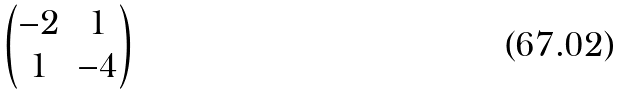Convert formula to latex. <formula><loc_0><loc_0><loc_500><loc_500>\begin{pmatrix} - 2 & 1 \\ 1 & - 4 \end{pmatrix}</formula> 